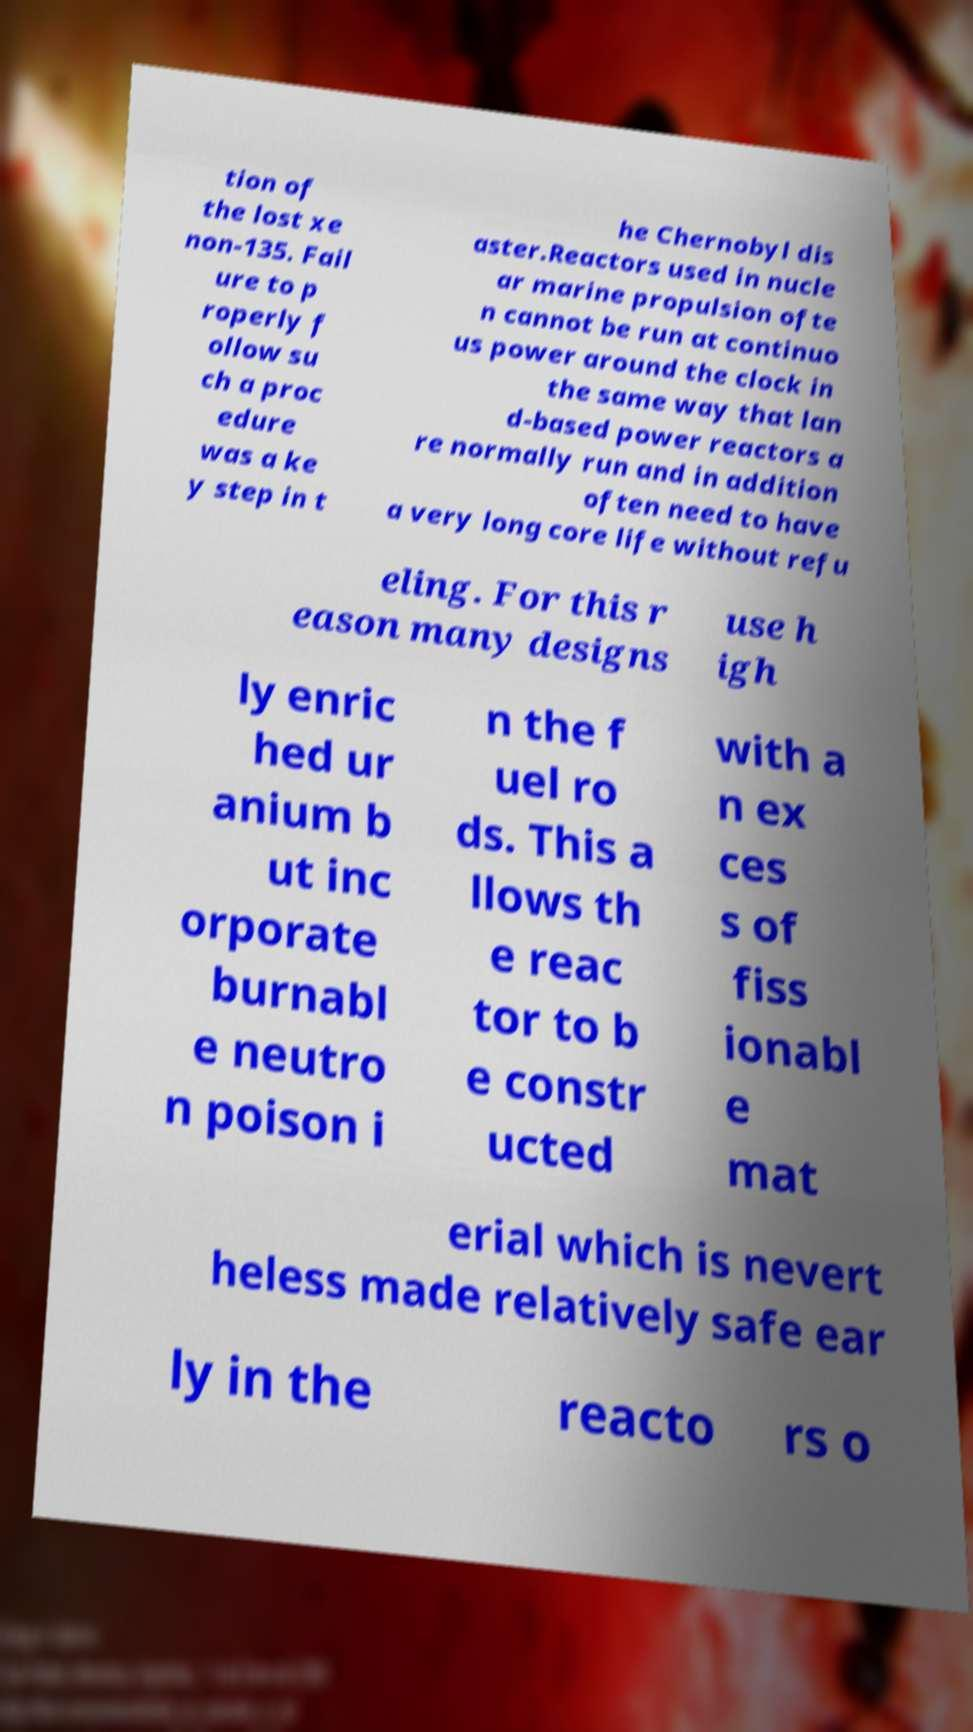Could you extract and type out the text from this image? tion of the lost xe non-135. Fail ure to p roperly f ollow su ch a proc edure was a ke y step in t he Chernobyl dis aster.Reactors used in nucle ar marine propulsion ofte n cannot be run at continuo us power around the clock in the same way that lan d-based power reactors a re normally run and in addition often need to have a very long core life without refu eling. For this r eason many designs use h igh ly enric hed ur anium b ut inc orporate burnabl e neutro n poison i n the f uel ro ds. This a llows th e reac tor to b e constr ucted with a n ex ces s of fiss ionabl e mat erial which is nevert heless made relatively safe ear ly in the reacto rs o 